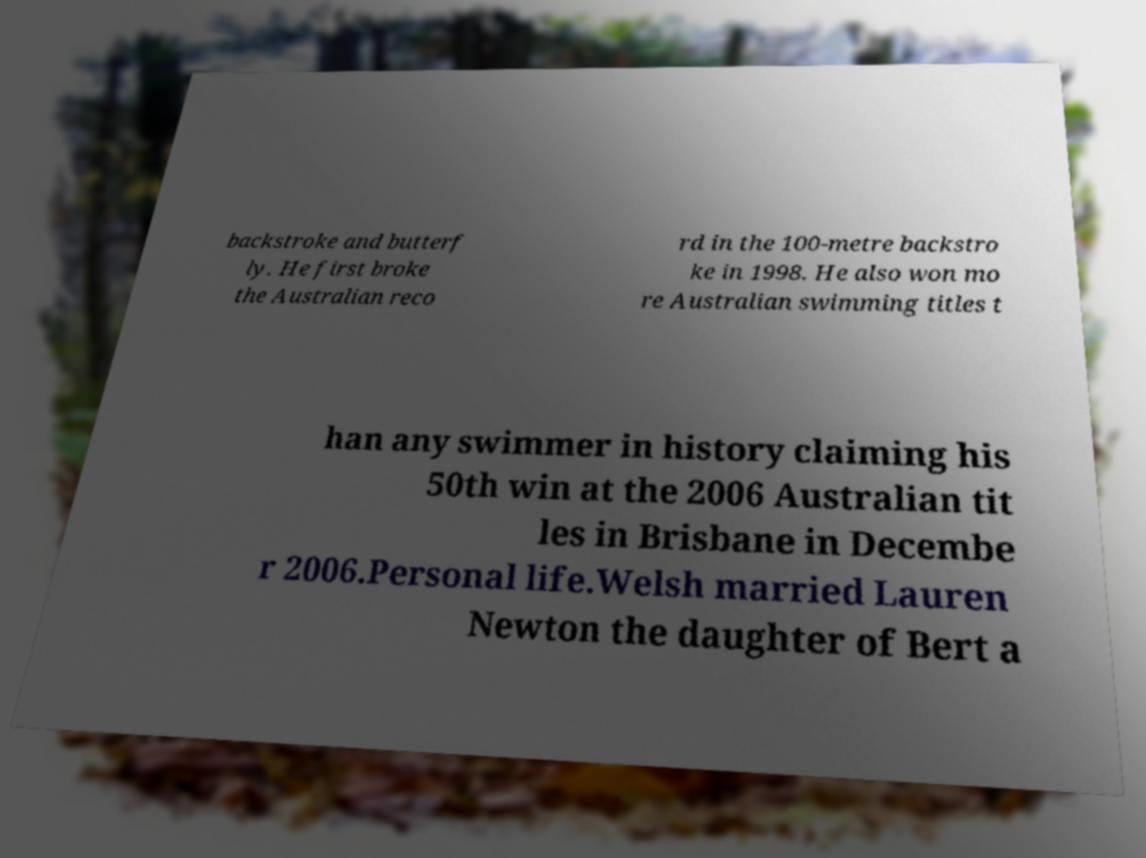Can you read and provide the text displayed in the image?This photo seems to have some interesting text. Can you extract and type it out for me? backstroke and butterf ly. He first broke the Australian reco rd in the 100-metre backstro ke in 1998. He also won mo re Australian swimming titles t han any swimmer in history claiming his 50th win at the 2006 Australian tit les in Brisbane in Decembe r 2006.Personal life.Welsh married Lauren Newton the daughter of Bert a 